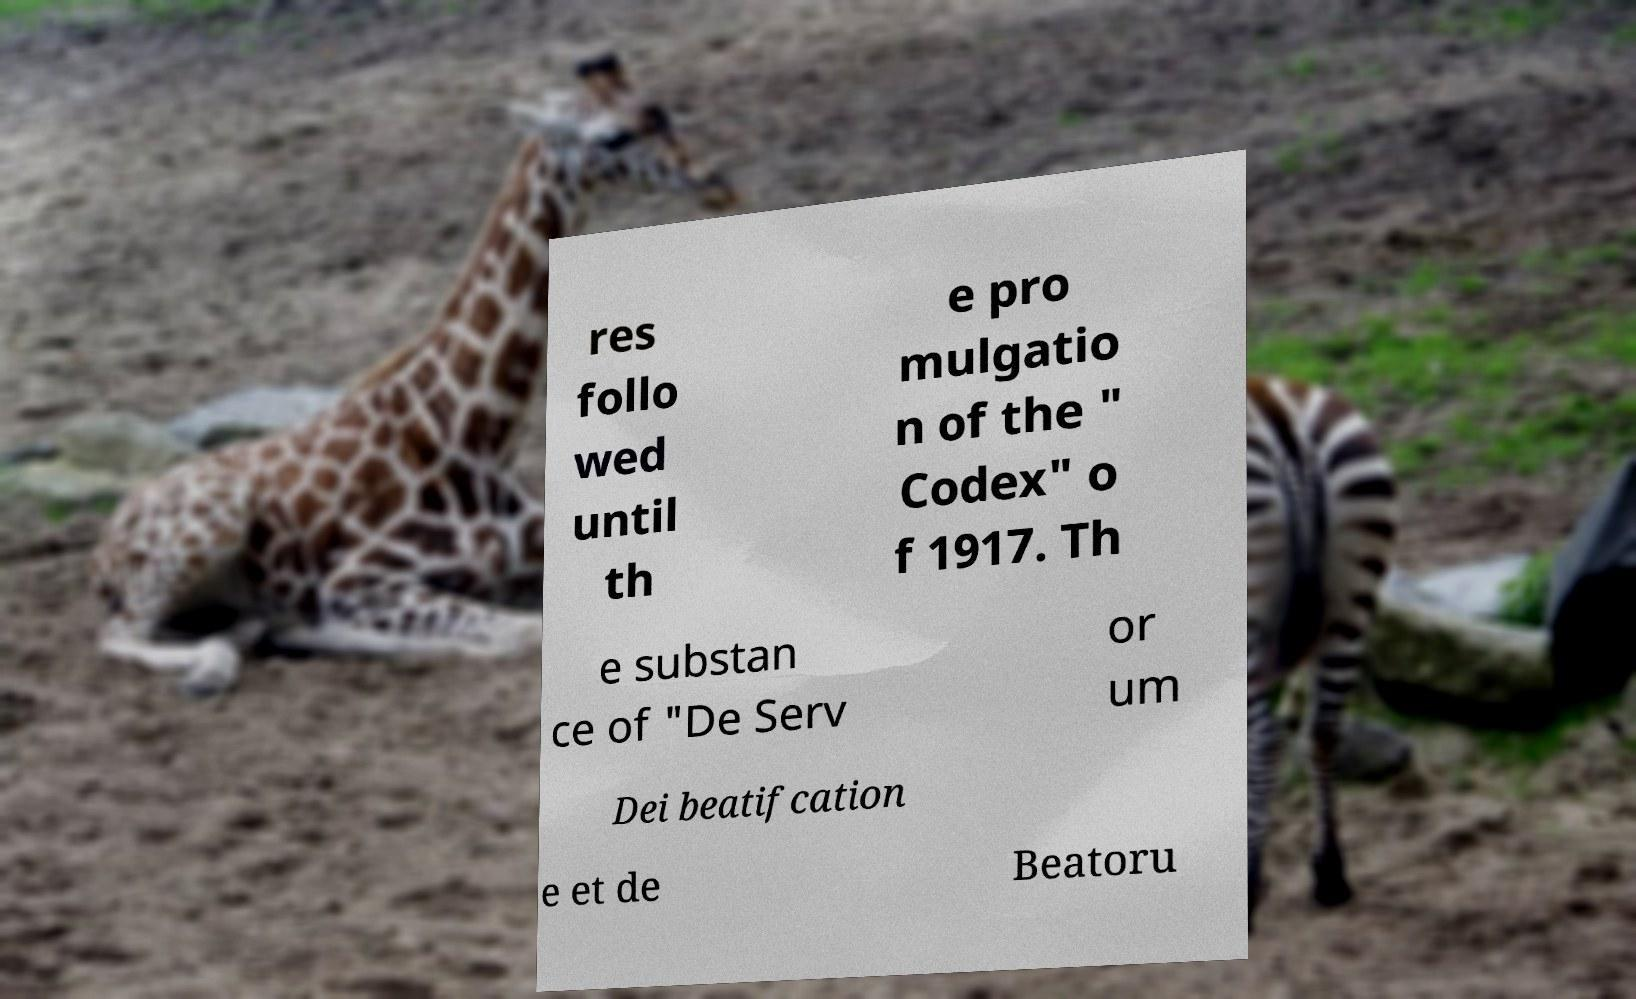Can you read and provide the text displayed in the image?This photo seems to have some interesting text. Can you extract and type it out for me? res follo wed until th e pro mulgatio n of the " Codex" o f 1917. Th e substan ce of "De Serv or um Dei beatifcation e et de Beatoru 